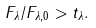<formula> <loc_0><loc_0><loc_500><loc_500>F _ { \lambda } / F _ { \lambda , 0 } > t _ { \lambda } .</formula> 